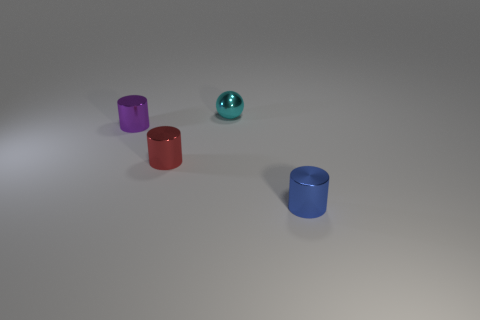There is a tiny cylinder that is in front of the purple metal cylinder and on the left side of the metal ball; what material is it made of?
Offer a very short reply. Metal. What number of objects are either metallic objects that are in front of the purple cylinder or large blue objects?
Offer a terse response. 2. Are there any other objects that have the same size as the blue metal thing?
Ensure brevity in your answer.  Yes. What number of things are behind the small purple metal thing and in front of the purple thing?
Make the answer very short. 0. There is a cyan shiny object; what number of tiny cyan things are to the right of it?
Keep it short and to the point. 0. Are there any blue objects that have the same shape as the cyan thing?
Offer a terse response. No. There is a purple object; is it the same shape as the small metallic thing to the right of the ball?
Your answer should be compact. Yes. What number of spheres are yellow rubber objects or blue metal objects?
Your answer should be very brief. 0. The shiny object that is to the right of the cyan sphere has what shape?
Your answer should be compact. Cylinder. How many tiny red cubes are the same material as the small sphere?
Your response must be concise. 0. 